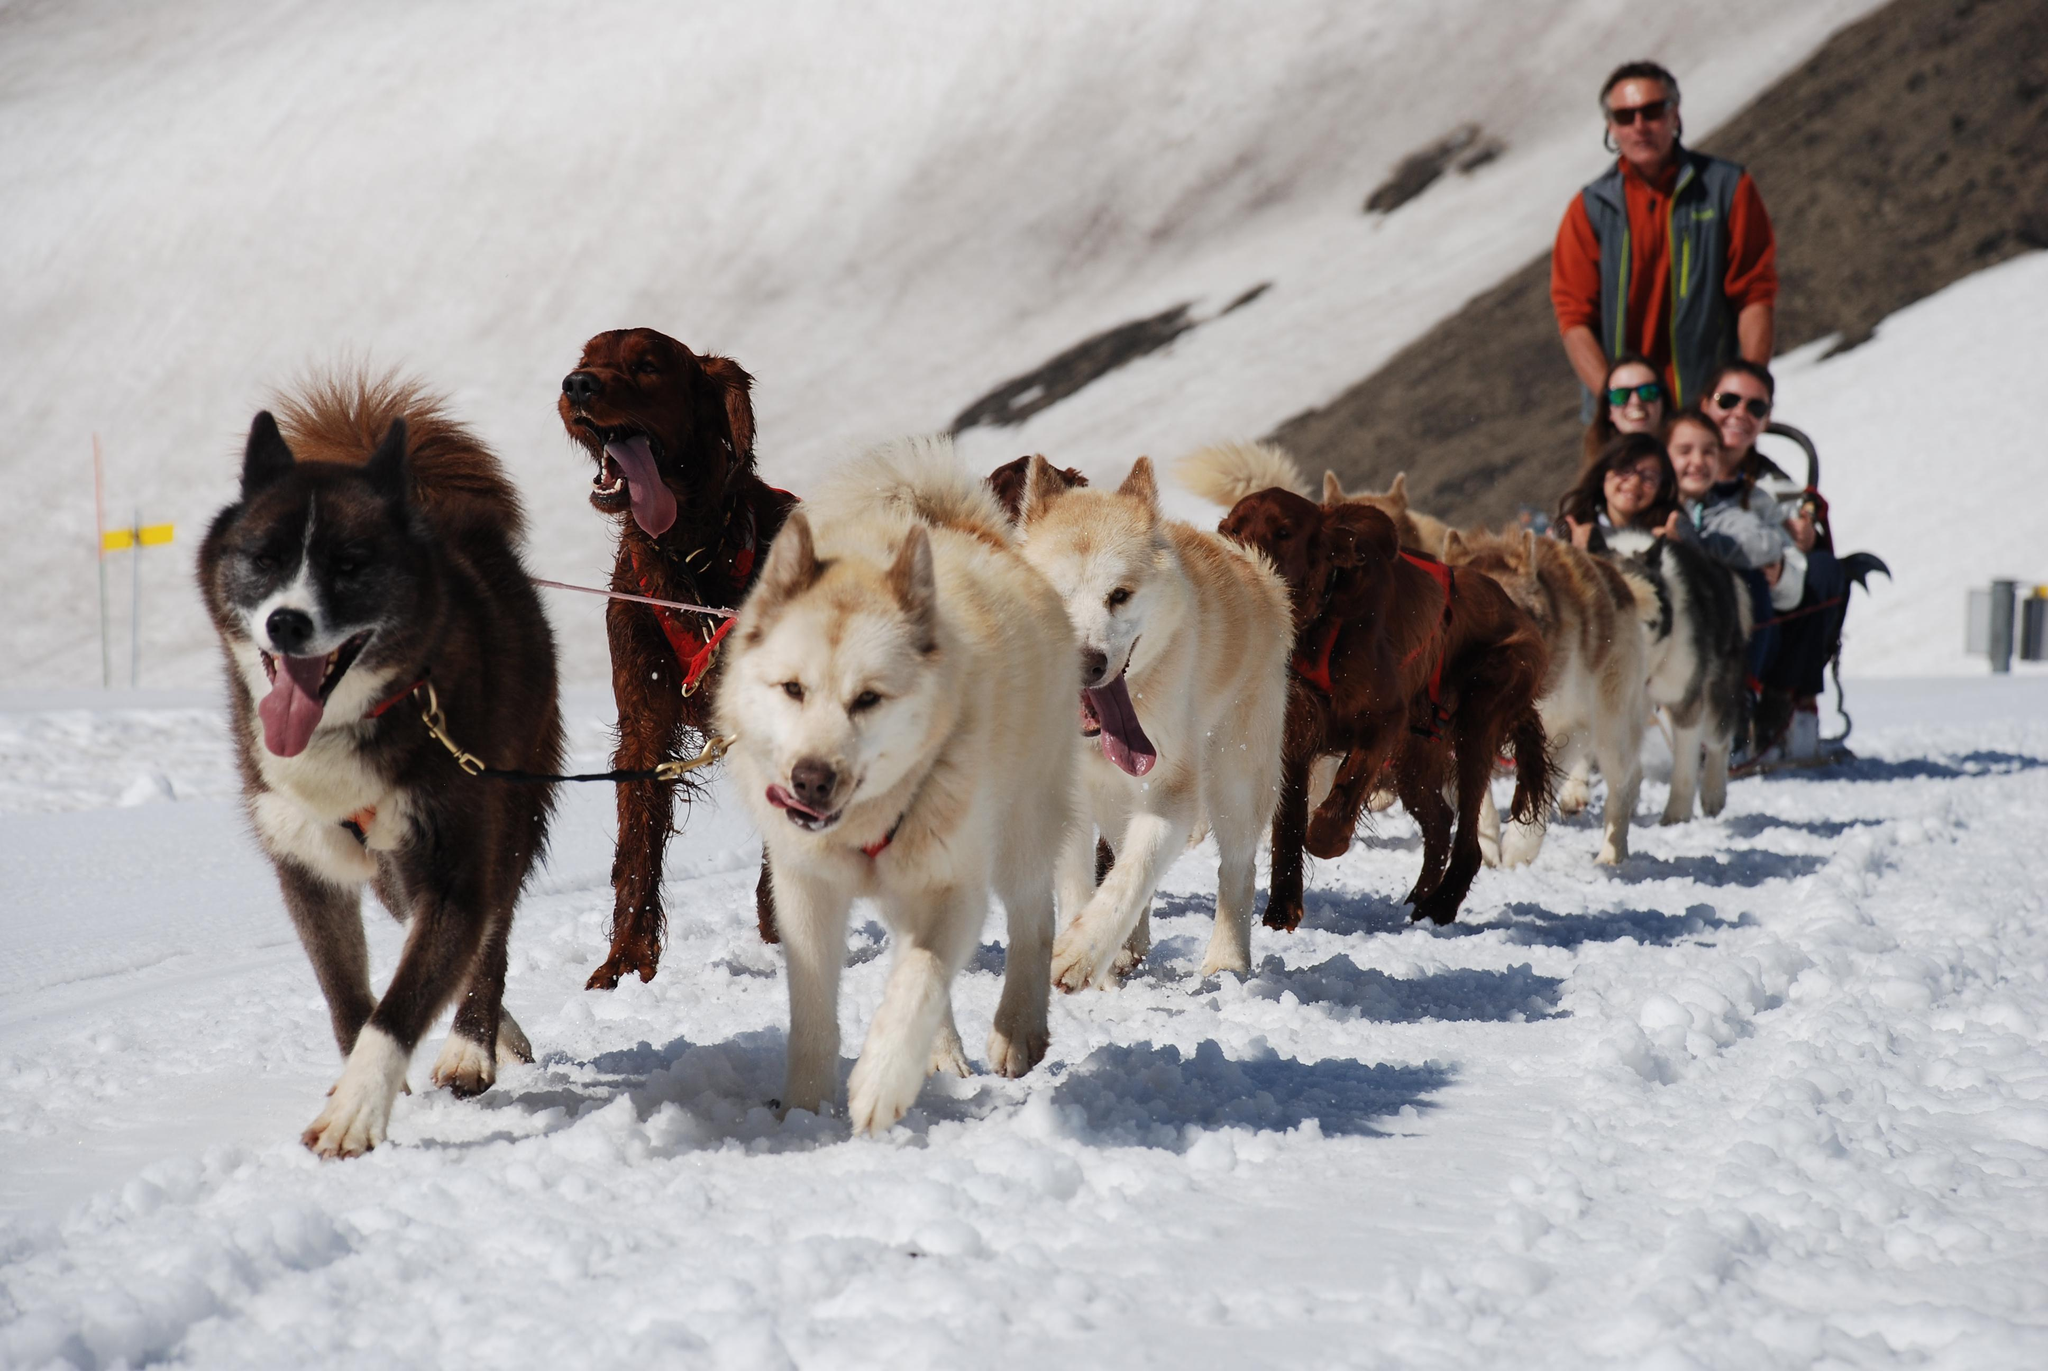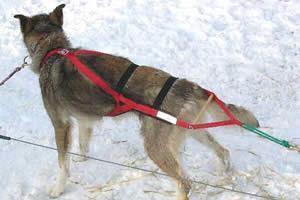The first image is the image on the left, the second image is the image on the right. Examine the images to the left and right. Is the description "There are two huskies in red harness standing on the snow." accurate? Answer yes or no. No. The first image is the image on the left, the second image is the image on the right. Analyze the images presented: Is the assertion "Some dogs are moving forward." valid? Answer yes or no. Yes. 